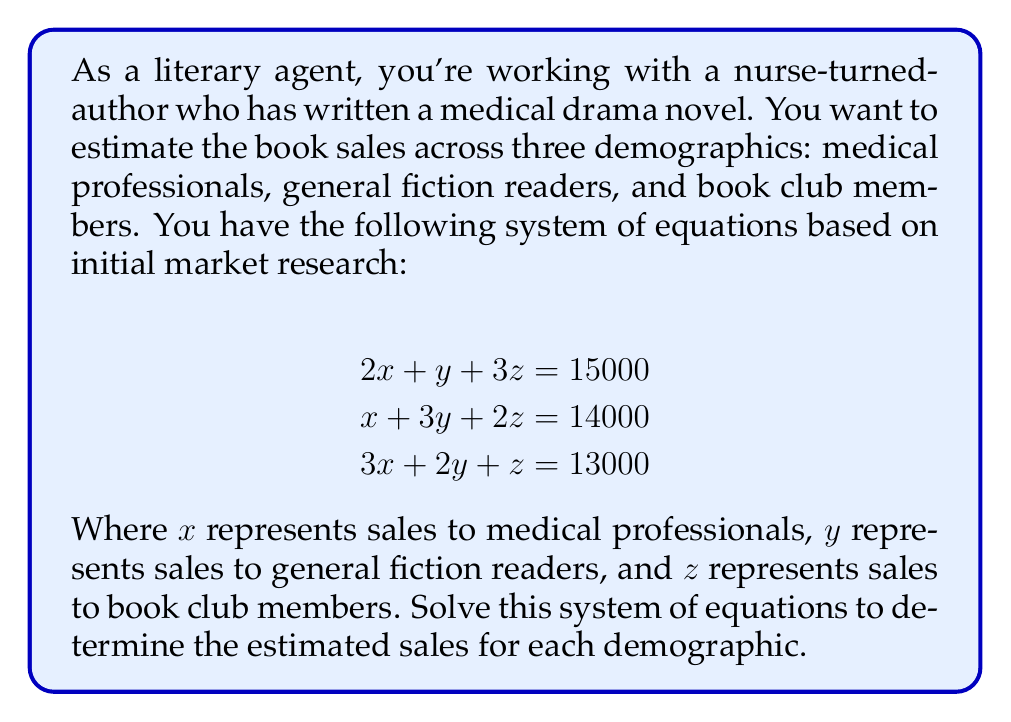Can you answer this question? To solve this system of equations, we'll use the elimination method:

1) First, let's eliminate $x$ by multiplying the first equation by 3 and the third equation by -2:

   $$\begin{align}
   6x + 3y + 9z &= 45000 \\
   -6x - 4y - 2z &= -26000
   \end{align}$$

   Adding these equations:
   $$-y + 7z = 19000 \quad (Equation 4)$$

2) Now, let's eliminate $x$ using the first and second equations. Multiply the first equation by 1 and the second by -2:

   $$\begin{align}
   2x + y + 3z &= 15000 \\
   -2x - 6y - 4z &= -28000
   \end{align}$$

   Adding these equations:
   $$-5y - z = -13000 \quad (Equation 5)$$

3) Now we have two equations with two unknowns (y and z):

   $$\begin{align}
   -y + 7z &= 19000 \quad (Equation 4) \\
   -5y - z &= -13000 \quad (Equation 5)
   \end{align}$$

4) Multiply Equation 5 by 7:
   $$-35y - 7z = -91000 \quad (Equation 6)$$

5) Add Equation 4 and Equation 6:
   $$-36y = -72000$$
   $$y = 2000$$

6) Substitute this value of $y$ into Equation 5:
   $$-5(2000) - z = -13000$$
   $$-10000 - z = -13000$$
   $$z = 3000$$

7) Now substitute these values of $y$ and $z$ into the first original equation:
   $$2x + 2000 + 3(3000) = 15000$$
   $$2x + 2000 + 9000 = 15000$$
   $$2x = 4000$$
   $$x = 2000$$

Therefore, the estimated sales are:
$x = 2000$ (medical professionals)
$y = 2000$ (general fiction readers)
$z = 3000$ (book club members)
Answer: Medical professionals: 2000 books
General fiction readers: 2000 books
Book club members: 3000 books 